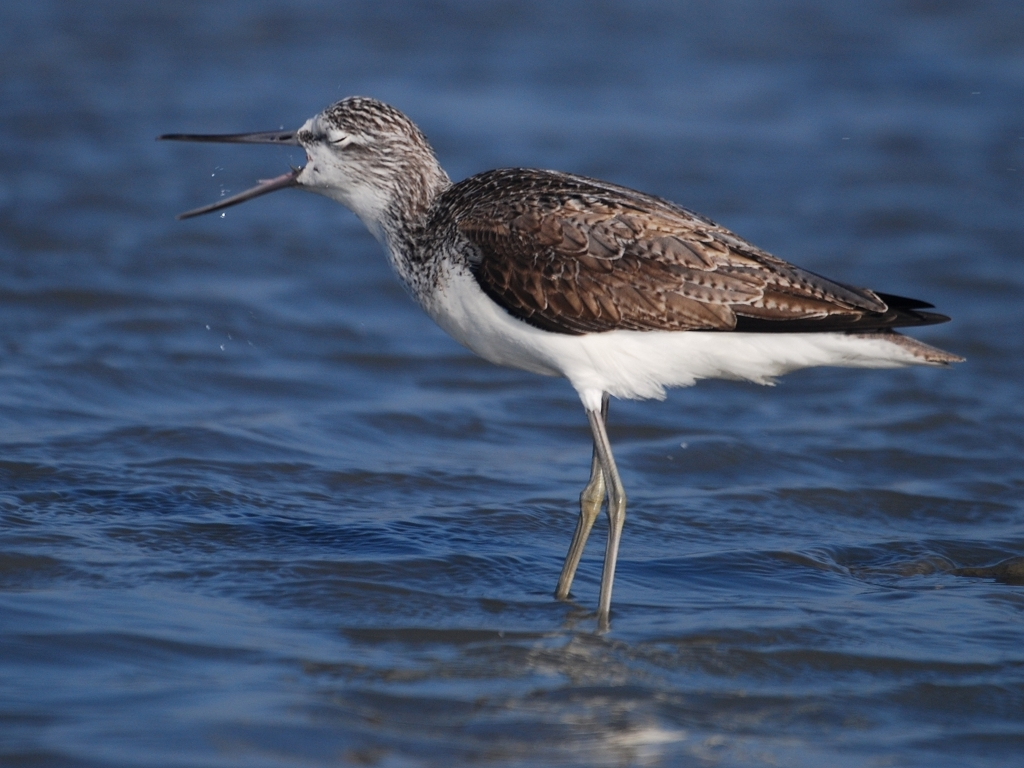What is the bird doing in this image? The bird is likely engaging in a behavior known as 'preening,' which is a maintenance behavior involving the use of its beak to clean and arrange its feathers. Why do birds engage in preening? Preening is essential for birds to maintain their feathers for optimal insulation, waterproofing, and flight. It also helps in removing parasites and aligning each feather in the optimum position. 